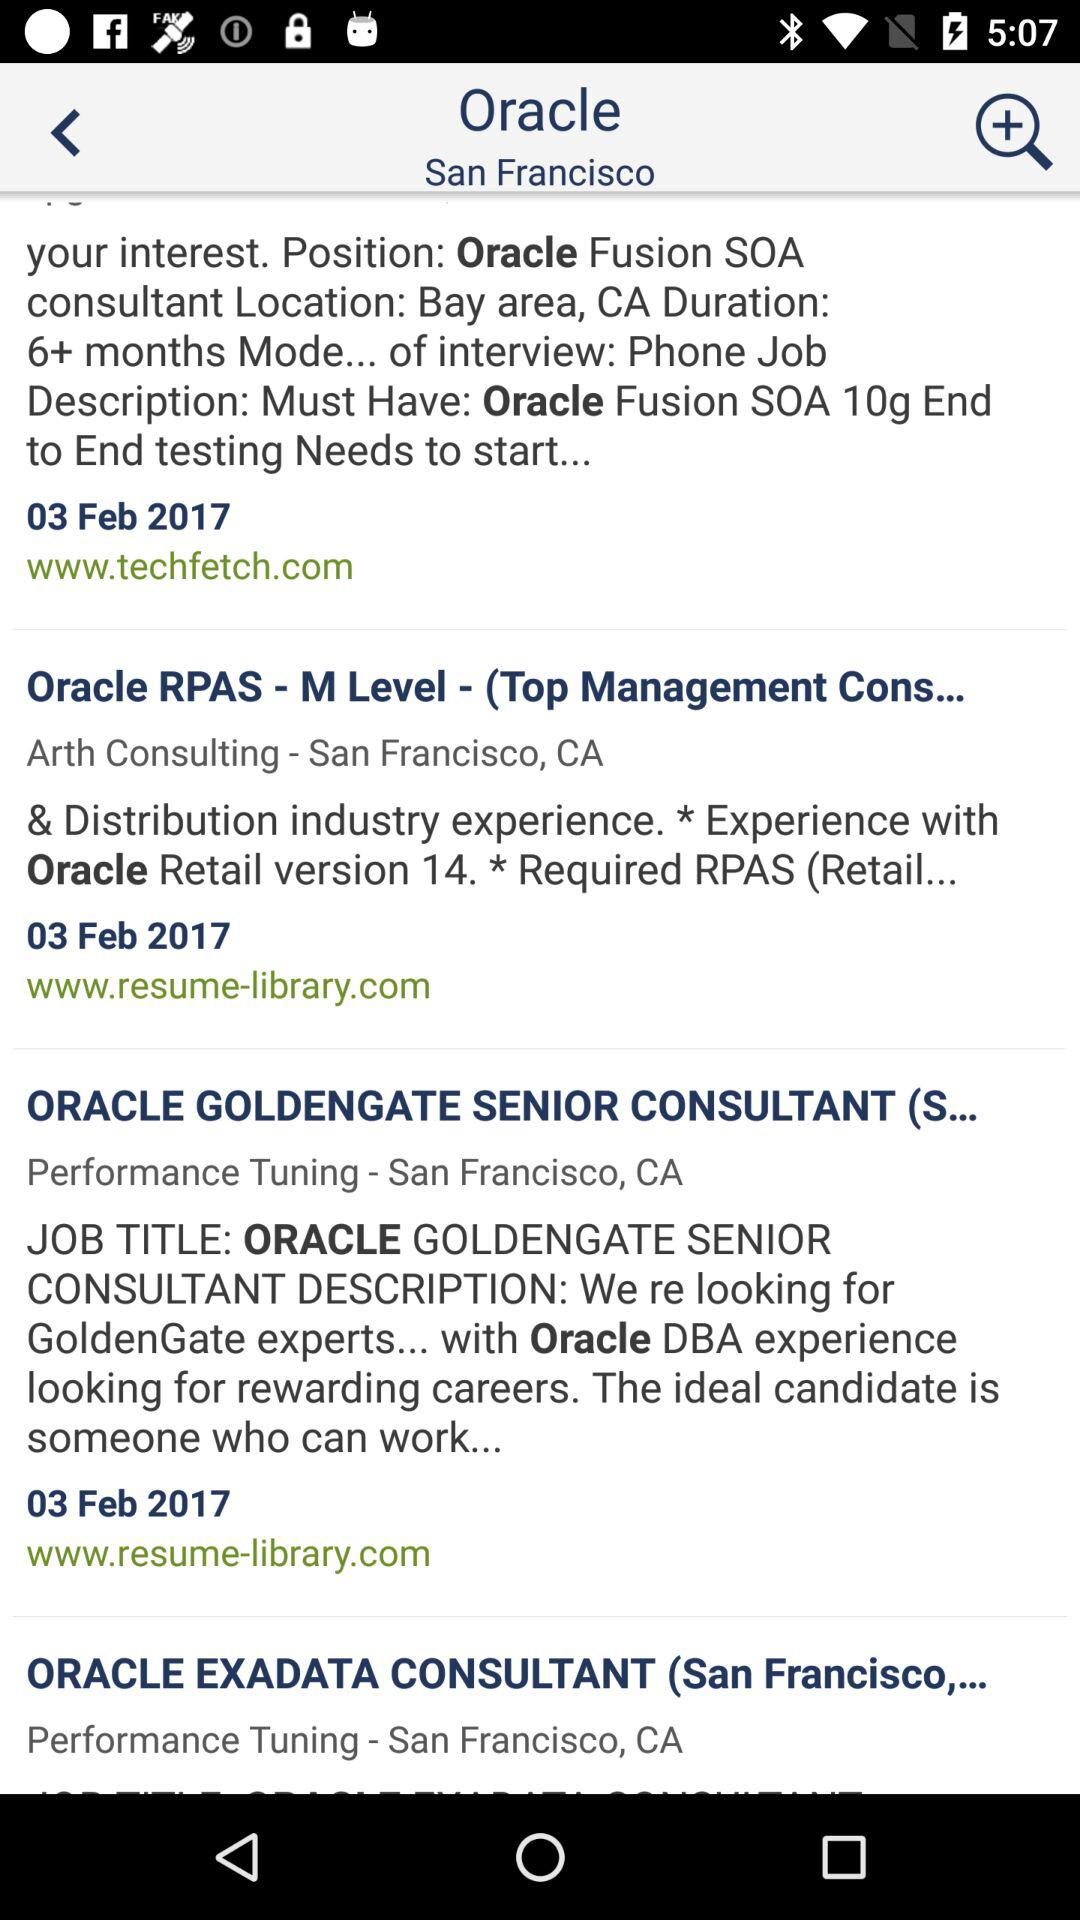What is the "Oracle" retail version number? The "Oracle" retail version number is 14. 